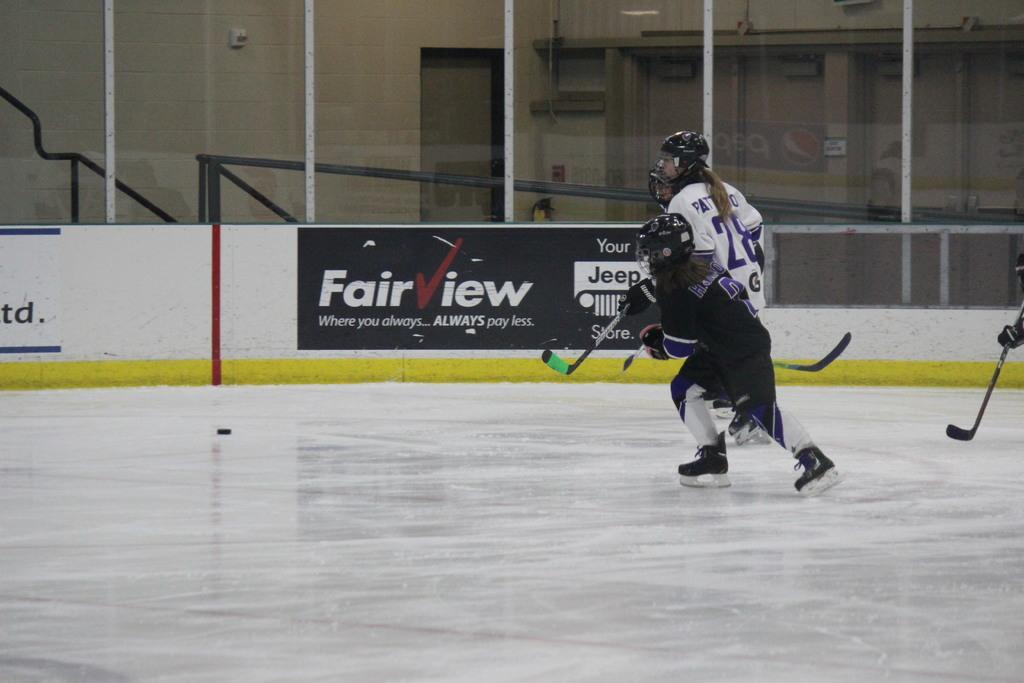Who is present in the image? There are people in the image. What are the people doing in the image? The people are playing with hockey sticks. What can be seen in the background of the image? There is a fencing in the background of the image. What type of music can be heard in the image? There is no music present in the image; it features people playing with hockey sticks and a background fencing. How many ducks are visible in the image? There are no ducks present in the image. 